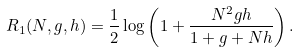Convert formula to latex. <formula><loc_0><loc_0><loc_500><loc_500>R _ { 1 } ( N , g , h ) = \frac { 1 } { 2 } \log \left ( 1 + \frac { N ^ { 2 } g h } { 1 + g + N h } \right ) .</formula> 